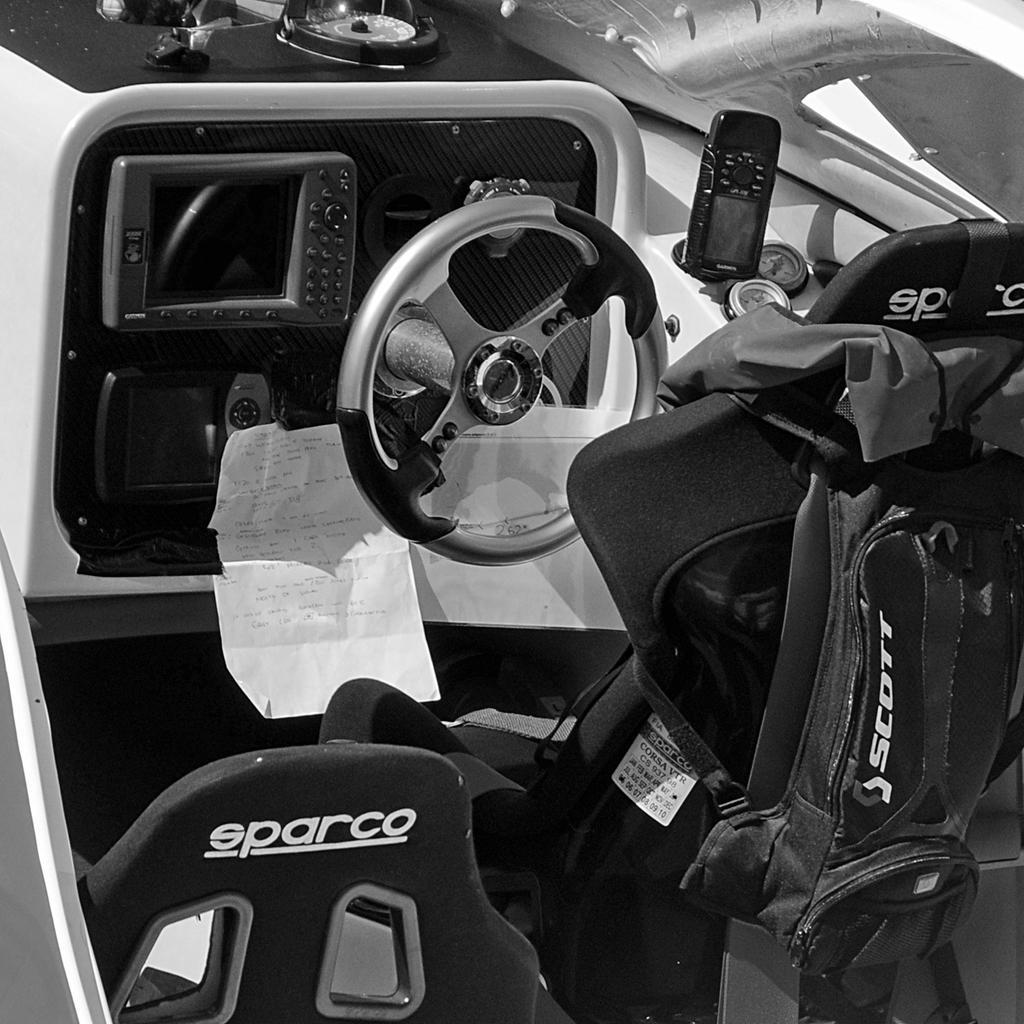Could you give a brief overview of what you see in this image? This black and white picture is clicked inside a vehicle. In the foreground there are car seats. To the right there is a belt on the car seat. In front of it there are display meters and a steering wheel. Beside it there is a remote. There is text on the seats. 